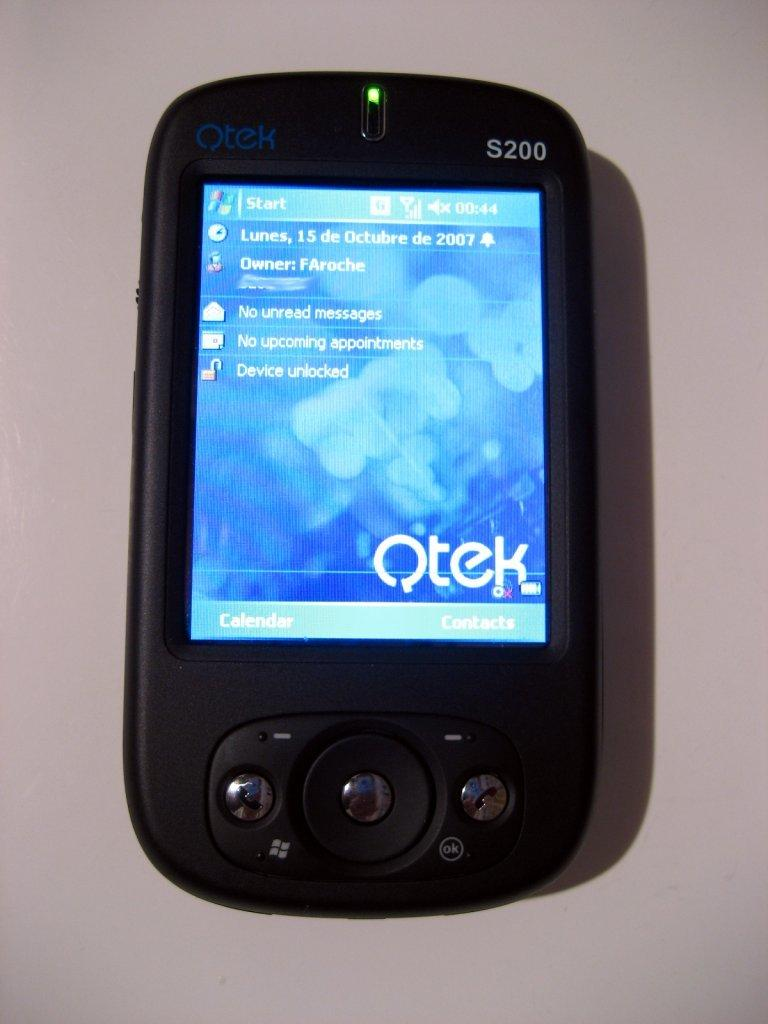<image>
Summarize the visual content of the image. FAroche has no upcoming appointments or current messages to read. 